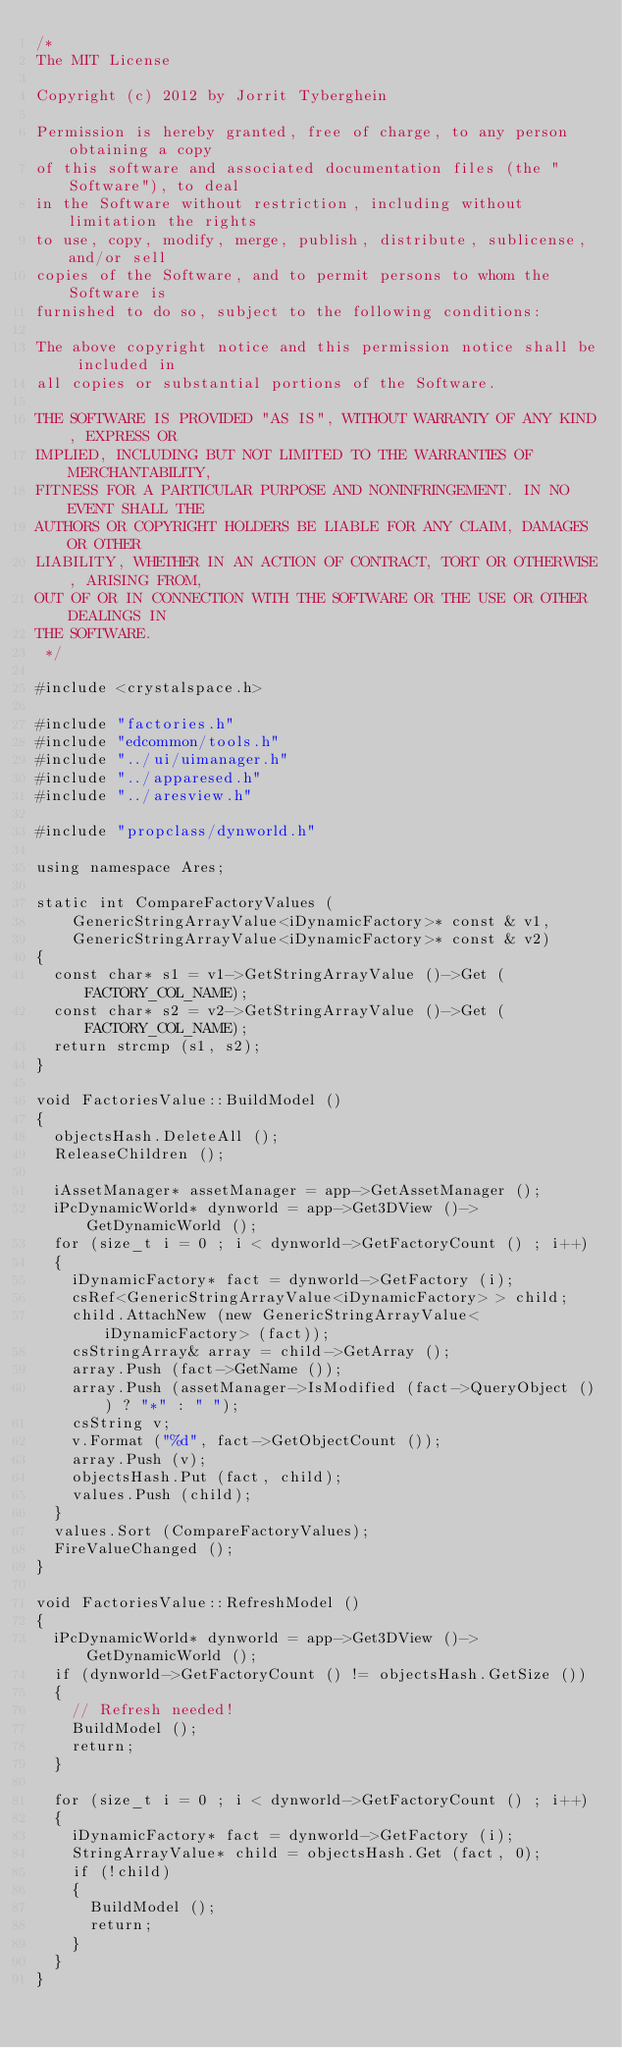Convert code to text. <code><loc_0><loc_0><loc_500><loc_500><_C++_>/*
The MIT License

Copyright (c) 2012 by Jorrit Tyberghein

Permission is hereby granted, free of charge, to any person obtaining a copy
of this software and associated documentation files (the "Software"), to deal
in the Software without restriction, including without limitation the rights
to use, copy, modify, merge, publish, distribute, sublicense, and/or sell
copies of the Software, and to permit persons to whom the Software is
furnished to do so, subject to the following conditions:

The above copyright notice and this permission notice shall be included in
all copies or substantial portions of the Software.

THE SOFTWARE IS PROVIDED "AS IS", WITHOUT WARRANTY OF ANY KIND, EXPRESS OR
IMPLIED, INCLUDING BUT NOT LIMITED TO THE WARRANTIES OF MERCHANTABILITY,
FITNESS FOR A PARTICULAR PURPOSE AND NONINFRINGEMENT. IN NO EVENT SHALL THE
AUTHORS OR COPYRIGHT HOLDERS BE LIABLE FOR ANY CLAIM, DAMAGES OR OTHER
LIABILITY, WHETHER IN AN ACTION OF CONTRACT, TORT OR OTHERWISE, ARISING FROM,
OUT OF OR IN CONNECTION WITH THE SOFTWARE OR THE USE OR OTHER DEALINGS IN
THE SOFTWARE.
 */

#include <crystalspace.h>

#include "factories.h"
#include "edcommon/tools.h"
#include "../ui/uimanager.h"
#include "../apparesed.h"
#include "../aresview.h"

#include "propclass/dynworld.h"

using namespace Ares;

static int CompareFactoryValues (
    GenericStringArrayValue<iDynamicFactory>* const & v1,
    GenericStringArrayValue<iDynamicFactory>* const & v2)
{
  const char* s1 = v1->GetStringArrayValue ()->Get (FACTORY_COL_NAME);
  const char* s2 = v2->GetStringArrayValue ()->Get (FACTORY_COL_NAME);
  return strcmp (s1, s2);
}

void FactoriesValue::BuildModel ()
{
  objectsHash.DeleteAll ();
  ReleaseChildren ();

  iAssetManager* assetManager = app->GetAssetManager ();
  iPcDynamicWorld* dynworld = app->Get3DView ()->GetDynamicWorld ();
  for (size_t i = 0 ; i < dynworld->GetFactoryCount () ; i++)
  {
    iDynamicFactory* fact = dynworld->GetFactory (i);
    csRef<GenericStringArrayValue<iDynamicFactory> > child;
    child.AttachNew (new GenericStringArrayValue<iDynamicFactory> (fact));
    csStringArray& array = child->GetArray ();
    array.Push (fact->GetName ());
    array.Push (assetManager->IsModified (fact->QueryObject ()) ? "*" : " ");
    csString v;
    v.Format ("%d", fact->GetObjectCount ());
    array.Push (v);
    objectsHash.Put (fact, child);
    values.Push (child);
  }
  values.Sort (CompareFactoryValues);
  FireValueChanged ();
}

void FactoriesValue::RefreshModel ()
{
  iPcDynamicWorld* dynworld = app->Get3DView ()->GetDynamicWorld ();
  if (dynworld->GetFactoryCount () != objectsHash.GetSize ())
  {
    // Refresh needed!
    BuildModel ();
    return;
  }

  for (size_t i = 0 ; i < dynworld->GetFactoryCount () ; i++)
  {
    iDynamicFactory* fact = dynworld->GetFactory (i);
    StringArrayValue* child = objectsHash.Get (fact, 0);
    if (!child)
    {
      BuildModel ();
      return;
    }
  }
}


</code> 